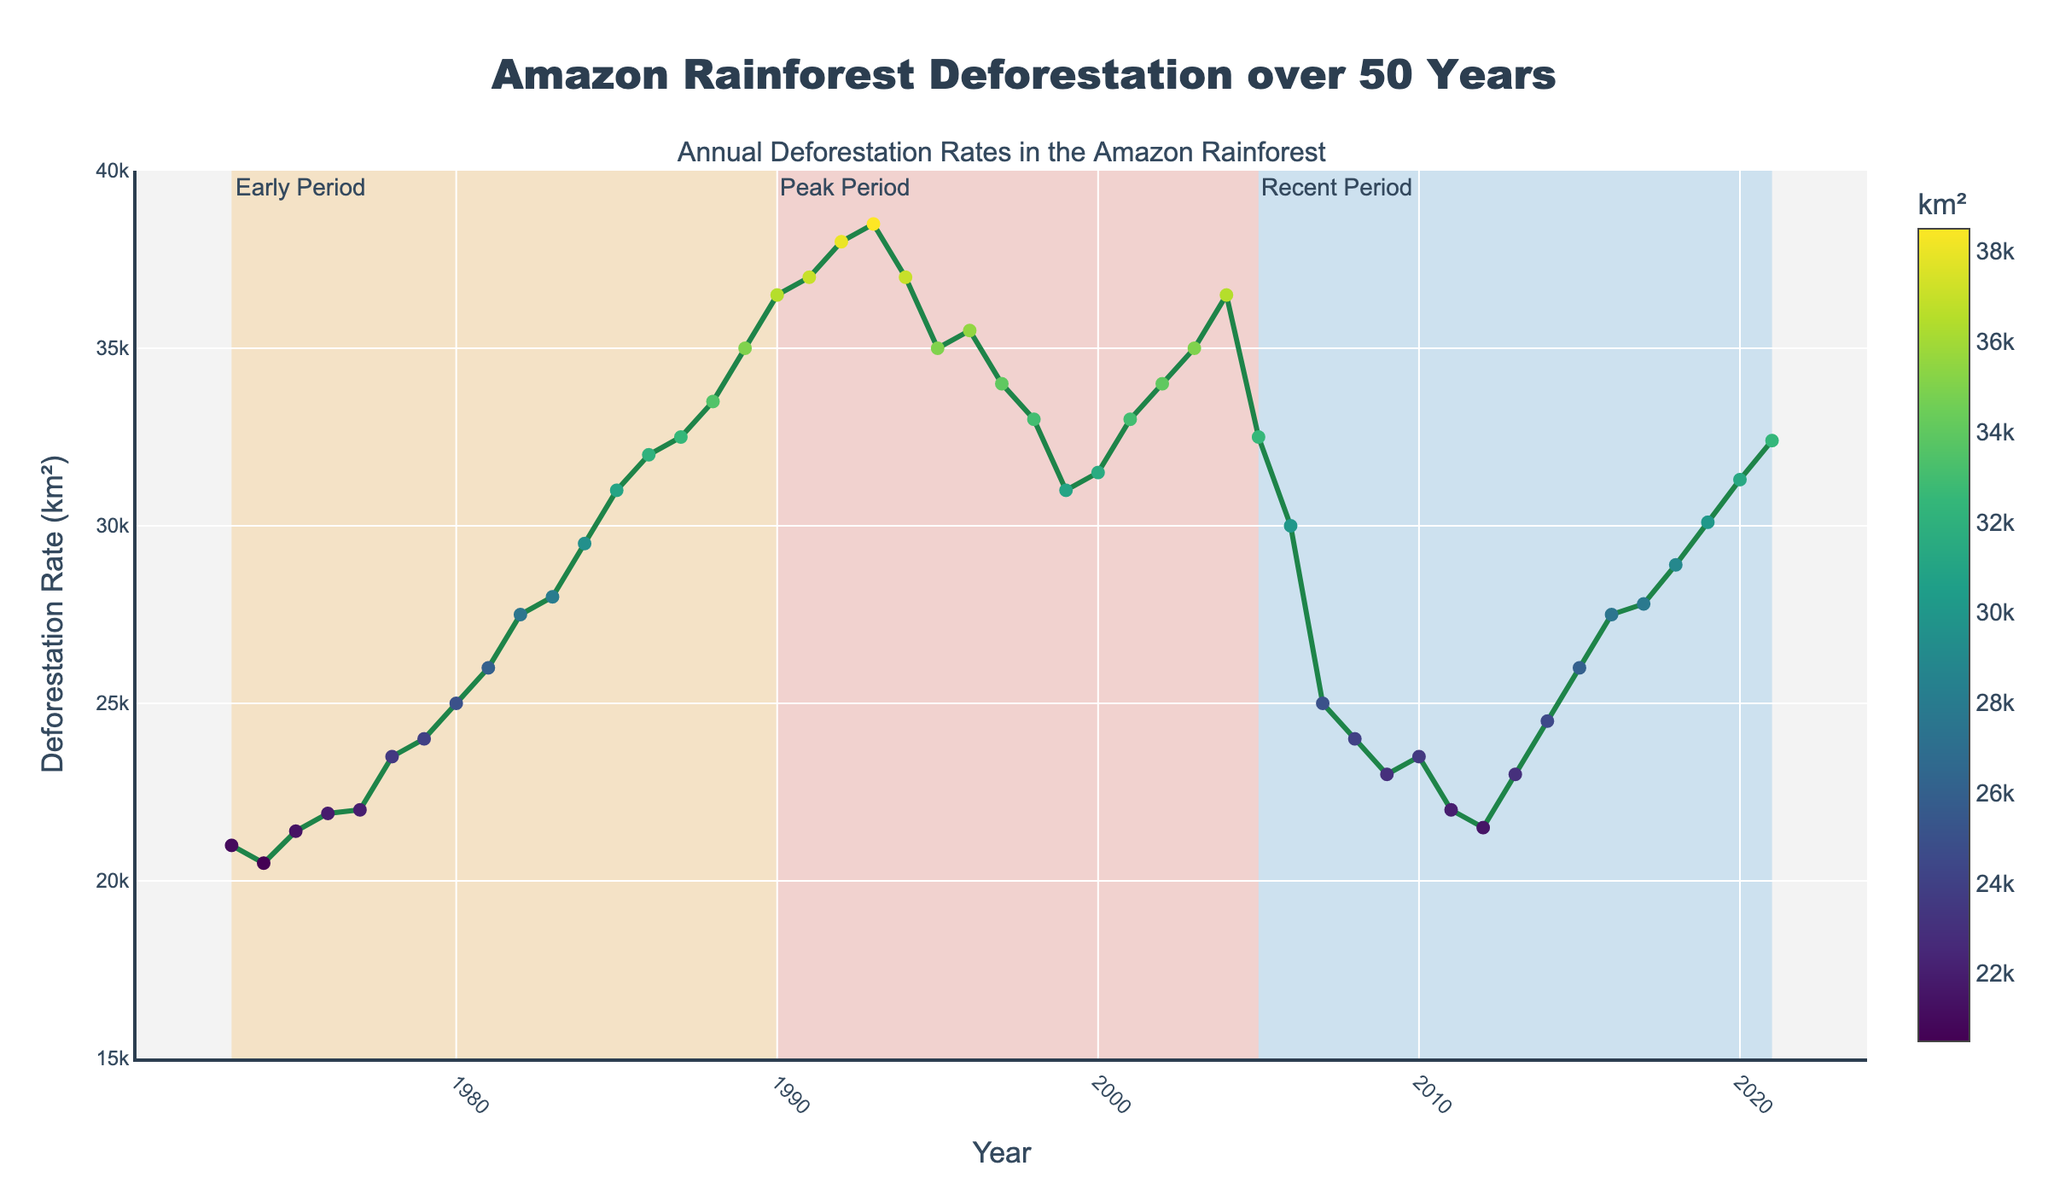How many shaded periods are there in the plot? By observing the plot, we can see there are three distinct shaded areas each representing different periods.
Answer: 3 What is the highest deforestation rate recorded and in which year? By looking at the y-axis and the plotted lines, the highest deforestation rate is about 38,500 km² in the year 1992.
Answer: 38,500 km² in 1992 During which period did the deforestation rate start to decrease? The plot shows a decrease in deforestation rates after the "Peak Period" which ends in 2005. The rates decline significantly in the "Recent Period".
Answer: Recent Period Compare the deforestation rate in 1973 and 2021. Which year had a higher rate and by how much? The deforestation rate in 1973 is 21,000 km² and in 2021 it is 32,400 km². To find the difference, subtract the two values: 32,400 - 21,000 = 11,400 km². Thus, 2021 had a higher rate by 11,400 km².
Answer: 2021 by 11,400 km² Did any year in the "Recent Period" have a higher deforestation rate than the peak value in the "Peak Period"? By examining the plot, the highest deforestation rate during the "Peak Period" is around 38,500 km² in 1992. In the "Recent Period", none of the years surpass this peak value.
Answer: No What are the general trends in deforestation rates before, during, and after the "Peak Period"? By analyzing the trends, we see that the deforestation rate is gradually increasing during the "Early Period", reaches its highest during the "Peak Period", and then decreases in the "Recent Period".
Answer: Increasing, peaking, then decreasing How much did the deforestation rate change from 1985 to 1995? The deforestation rate in 1985 is 31,000 km² and in 1995 it is 35,000 km². The change is calculated as 35,000 - 31,000 = 4,000 km².
Answer: 4,000 km² What is the most noticeable trend in the data from the "Early Period"? The most noticeable trend in the "Early Period" is a gradual increase in the deforestation rate.
Answer: Gradual increase Among the shaded periods, which one shows the most variation in deforestation rates? The "Peak Period" shows the most variation, with a significant rise to about 38,500 km² and then a gradual decline.
Answer: Peak Period Which year marks the beginning of a significant decline in the deforestation rate? The plot shows that after peaking around 2004, the deforestation rate significantly starts to decline from the year 2005 onward.
Answer: 2005 